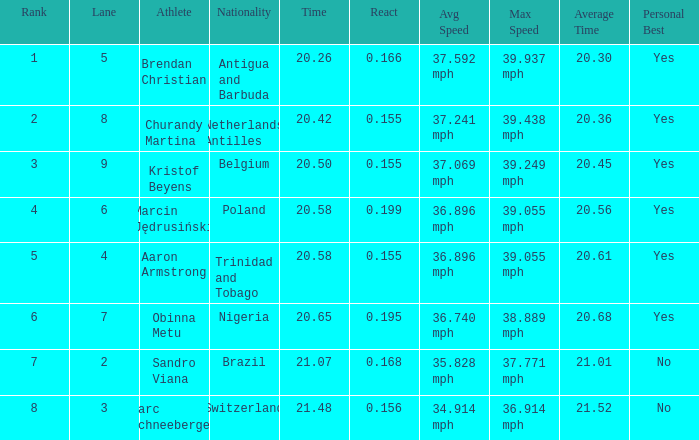How much Time has a Reaction of 0.155, and an Athlete of kristof beyens, and a Rank smaller than 3? 0.0. 